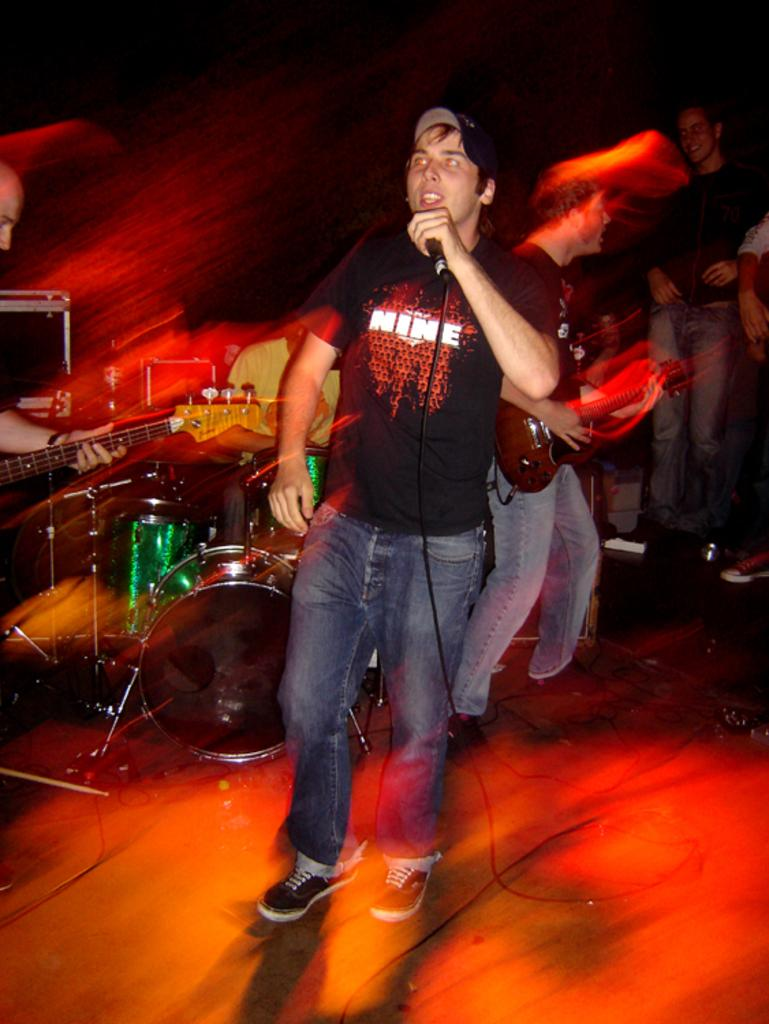What is the main subject of the image? There is a person in the image. What is the person wearing? The person is wearing a black shirt. What is the person doing in the image? The person is standing and singing. What object is in front of the person? There is a microphone in front of the person. What else can be seen in the image? There is a group of people playing music in the image. How many bottles of water are visible in the image? There are no bottles of water present in the image. What type of snakes can be seen slithering around the person's feet in the image? There are no snakes present in the image. 